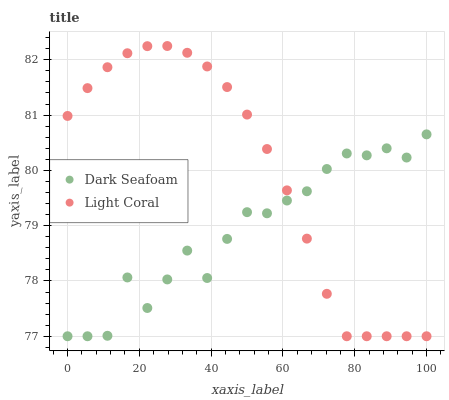Does Dark Seafoam have the minimum area under the curve?
Answer yes or no. Yes. Does Light Coral have the maximum area under the curve?
Answer yes or no. Yes. Does Dark Seafoam have the maximum area under the curve?
Answer yes or no. No. Is Light Coral the smoothest?
Answer yes or no. Yes. Is Dark Seafoam the roughest?
Answer yes or no. Yes. Is Dark Seafoam the smoothest?
Answer yes or no. No. Does Light Coral have the lowest value?
Answer yes or no. Yes. Does Light Coral have the highest value?
Answer yes or no. Yes. Does Dark Seafoam have the highest value?
Answer yes or no. No. Does Light Coral intersect Dark Seafoam?
Answer yes or no. Yes. Is Light Coral less than Dark Seafoam?
Answer yes or no. No. Is Light Coral greater than Dark Seafoam?
Answer yes or no. No. 